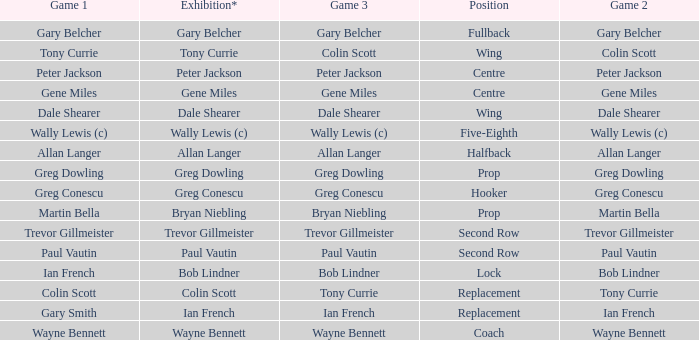What position has colin scott as game 1? Replacement. 